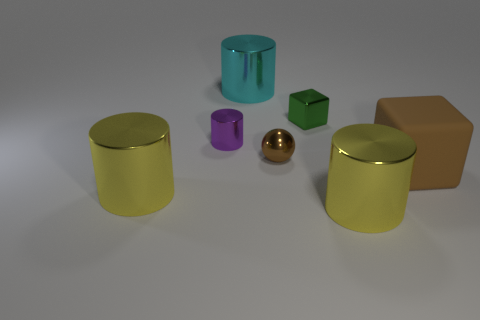If we imagine these objects grouped by category, could you suggest a possible categorization? Certainly! We could categorize them based on shape: cylinders (the yellow and teal cans, plus the small purple one), cube (the green one), sphere (the golden ball), and rectangular prism (the brown box). Alternatively, we could group them by size or reflectiveness of their surfaces. 